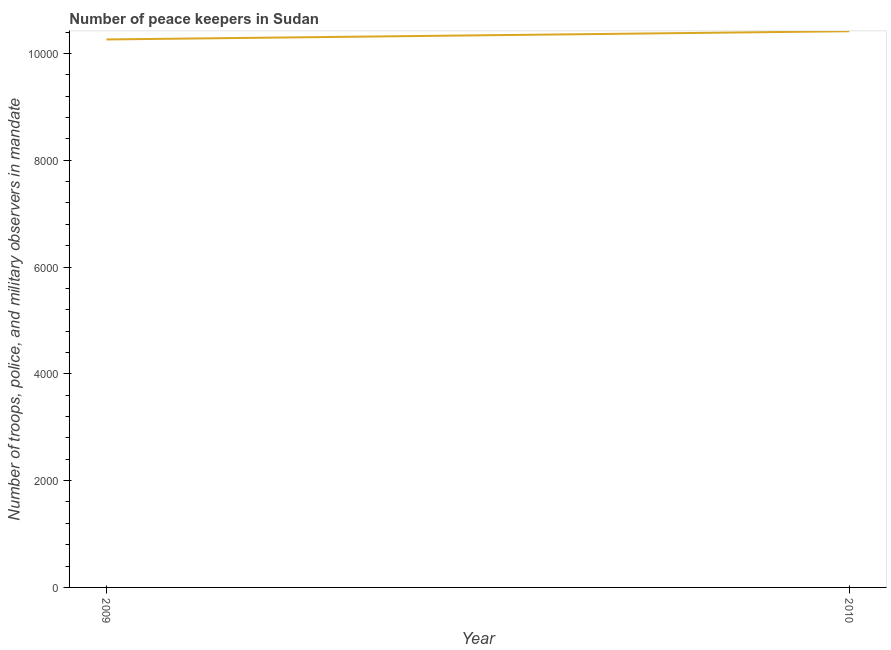What is the number of peace keepers in 2009?
Provide a succinct answer. 1.03e+04. Across all years, what is the maximum number of peace keepers?
Give a very brief answer. 1.04e+04. Across all years, what is the minimum number of peace keepers?
Offer a very short reply. 1.03e+04. In which year was the number of peace keepers maximum?
Give a very brief answer. 2010. In which year was the number of peace keepers minimum?
Your answer should be compact. 2009. What is the sum of the number of peace keepers?
Your response must be concise. 2.07e+04. What is the difference between the number of peace keepers in 2009 and 2010?
Provide a succinct answer. -154. What is the average number of peace keepers per year?
Provide a short and direct response. 1.03e+04. What is the median number of peace keepers?
Provide a short and direct response. 1.03e+04. Do a majority of the years between 2009 and 2010 (inclusive) have number of peace keepers greater than 7200 ?
Keep it short and to the point. Yes. What is the ratio of the number of peace keepers in 2009 to that in 2010?
Your answer should be very brief. 0.99. In how many years, is the number of peace keepers greater than the average number of peace keepers taken over all years?
Your response must be concise. 1. How many lines are there?
Offer a very short reply. 1. How many years are there in the graph?
Ensure brevity in your answer.  2. Are the values on the major ticks of Y-axis written in scientific E-notation?
Provide a succinct answer. No. What is the title of the graph?
Your answer should be very brief. Number of peace keepers in Sudan. What is the label or title of the Y-axis?
Make the answer very short. Number of troops, police, and military observers in mandate. What is the Number of troops, police, and military observers in mandate in 2009?
Your answer should be compact. 1.03e+04. What is the Number of troops, police, and military observers in mandate of 2010?
Provide a succinct answer. 1.04e+04. What is the difference between the Number of troops, police, and military observers in mandate in 2009 and 2010?
Offer a very short reply. -154. 